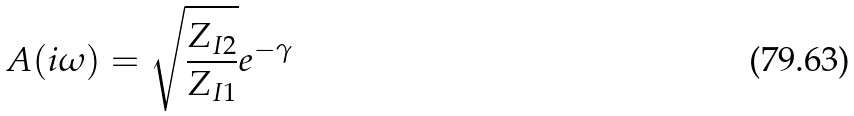Convert formula to latex. <formula><loc_0><loc_0><loc_500><loc_500>A ( i \omega ) = \sqrt { \frac { Z _ { I 2 } } { Z _ { I 1 } } } e ^ { - \gamma }</formula> 